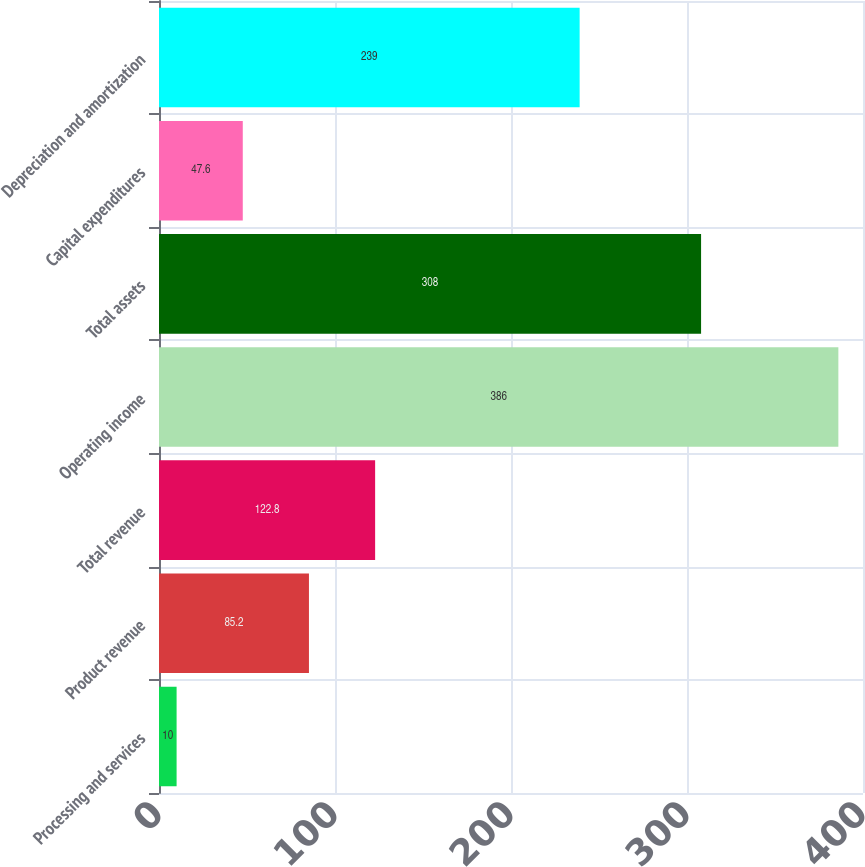Convert chart. <chart><loc_0><loc_0><loc_500><loc_500><bar_chart><fcel>Processing and services<fcel>Product revenue<fcel>Total revenue<fcel>Operating income<fcel>Total assets<fcel>Capital expenditures<fcel>Depreciation and amortization<nl><fcel>10<fcel>85.2<fcel>122.8<fcel>386<fcel>308<fcel>47.6<fcel>239<nl></chart> 